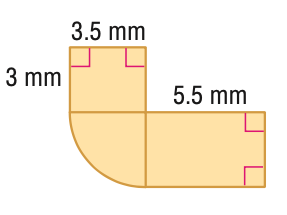Answer the mathemtical geometry problem and directly provide the correct option letter.
Question: Find the area of the figure. Round to the nearest tenth if necessary.
Choices: A: 39.4 B: 49.0 C: 68.2 D: 78.7 A 